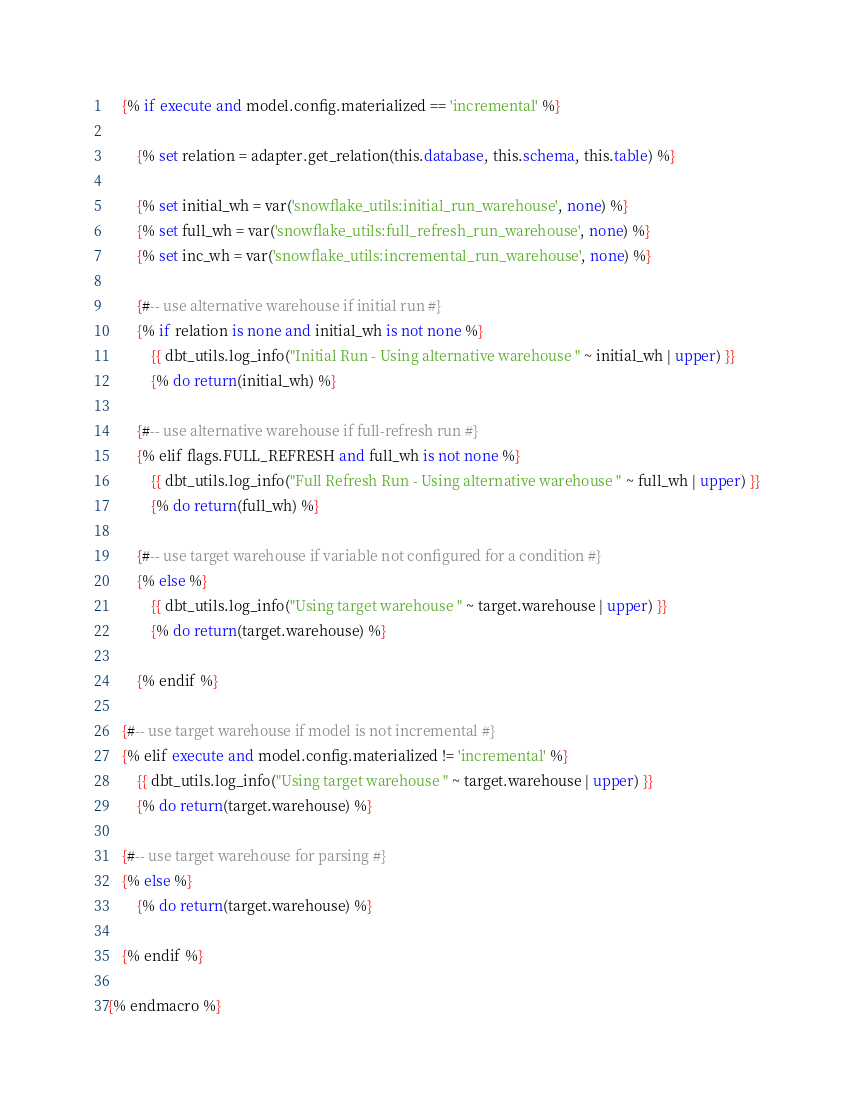<code> <loc_0><loc_0><loc_500><loc_500><_SQL_>
    {% if execute and model.config.materialized == 'incremental' %}

        {% set relation = adapter.get_relation(this.database, this.schema, this.table) %}

        {% set initial_wh = var('snowflake_utils:initial_run_warehouse', none) %}
        {% set full_wh = var('snowflake_utils:full_refresh_run_warehouse', none) %}
        {% set inc_wh = var('snowflake_utils:incremental_run_warehouse', none) %}

        {#-- use alternative warehouse if initial run #}
        {% if relation is none and initial_wh is not none %}
            {{ dbt_utils.log_info("Initial Run - Using alternative warehouse " ~ initial_wh | upper) }}
            {% do return(initial_wh) %}

        {#-- use alternative warehouse if full-refresh run #}
        {% elif flags.FULL_REFRESH and full_wh is not none %}
            {{ dbt_utils.log_info("Full Refresh Run - Using alternative warehouse " ~ full_wh | upper) }}
            {% do return(full_wh) %}

        {#-- use target warehouse if variable not configured for a condition #}
        {% else %}
            {{ dbt_utils.log_info("Using target warehouse " ~ target.warehouse | upper) }}
            {% do return(target.warehouse) %}

        {% endif %}

    {#-- use target warehouse if model is not incremental #}
    {% elif execute and model.config.materialized != 'incremental' %}
        {{ dbt_utils.log_info("Using target warehouse " ~ target.warehouse | upper) }}
        {% do return(target.warehouse) %}

    {#-- use target warehouse for parsing #}
    {% else %}
        {% do return(target.warehouse) %}

    {% endif %}

{% endmacro %}</code> 